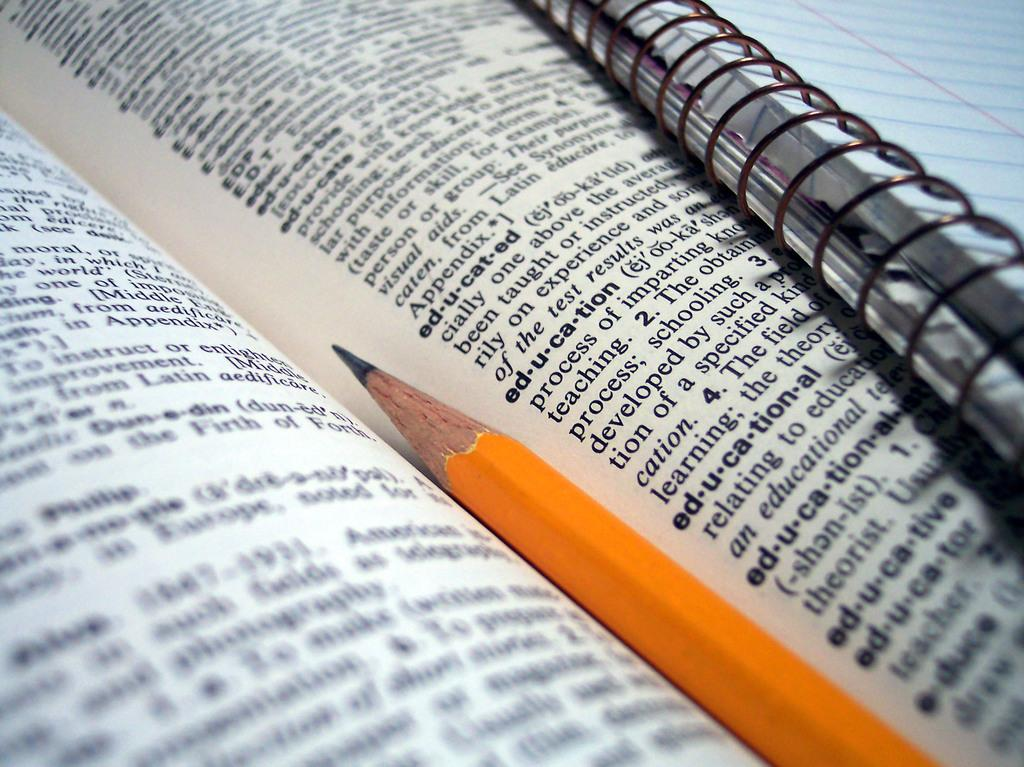<image>
Present a compact description of the photo's key features. A dictionary sitting open with the word Education in focus. 